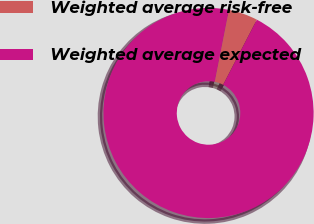Convert chart to OTSL. <chart><loc_0><loc_0><loc_500><loc_500><pie_chart><fcel>Weighted average risk-free<fcel>Weighted average expected<nl><fcel>4.51%<fcel>95.49%<nl></chart> 